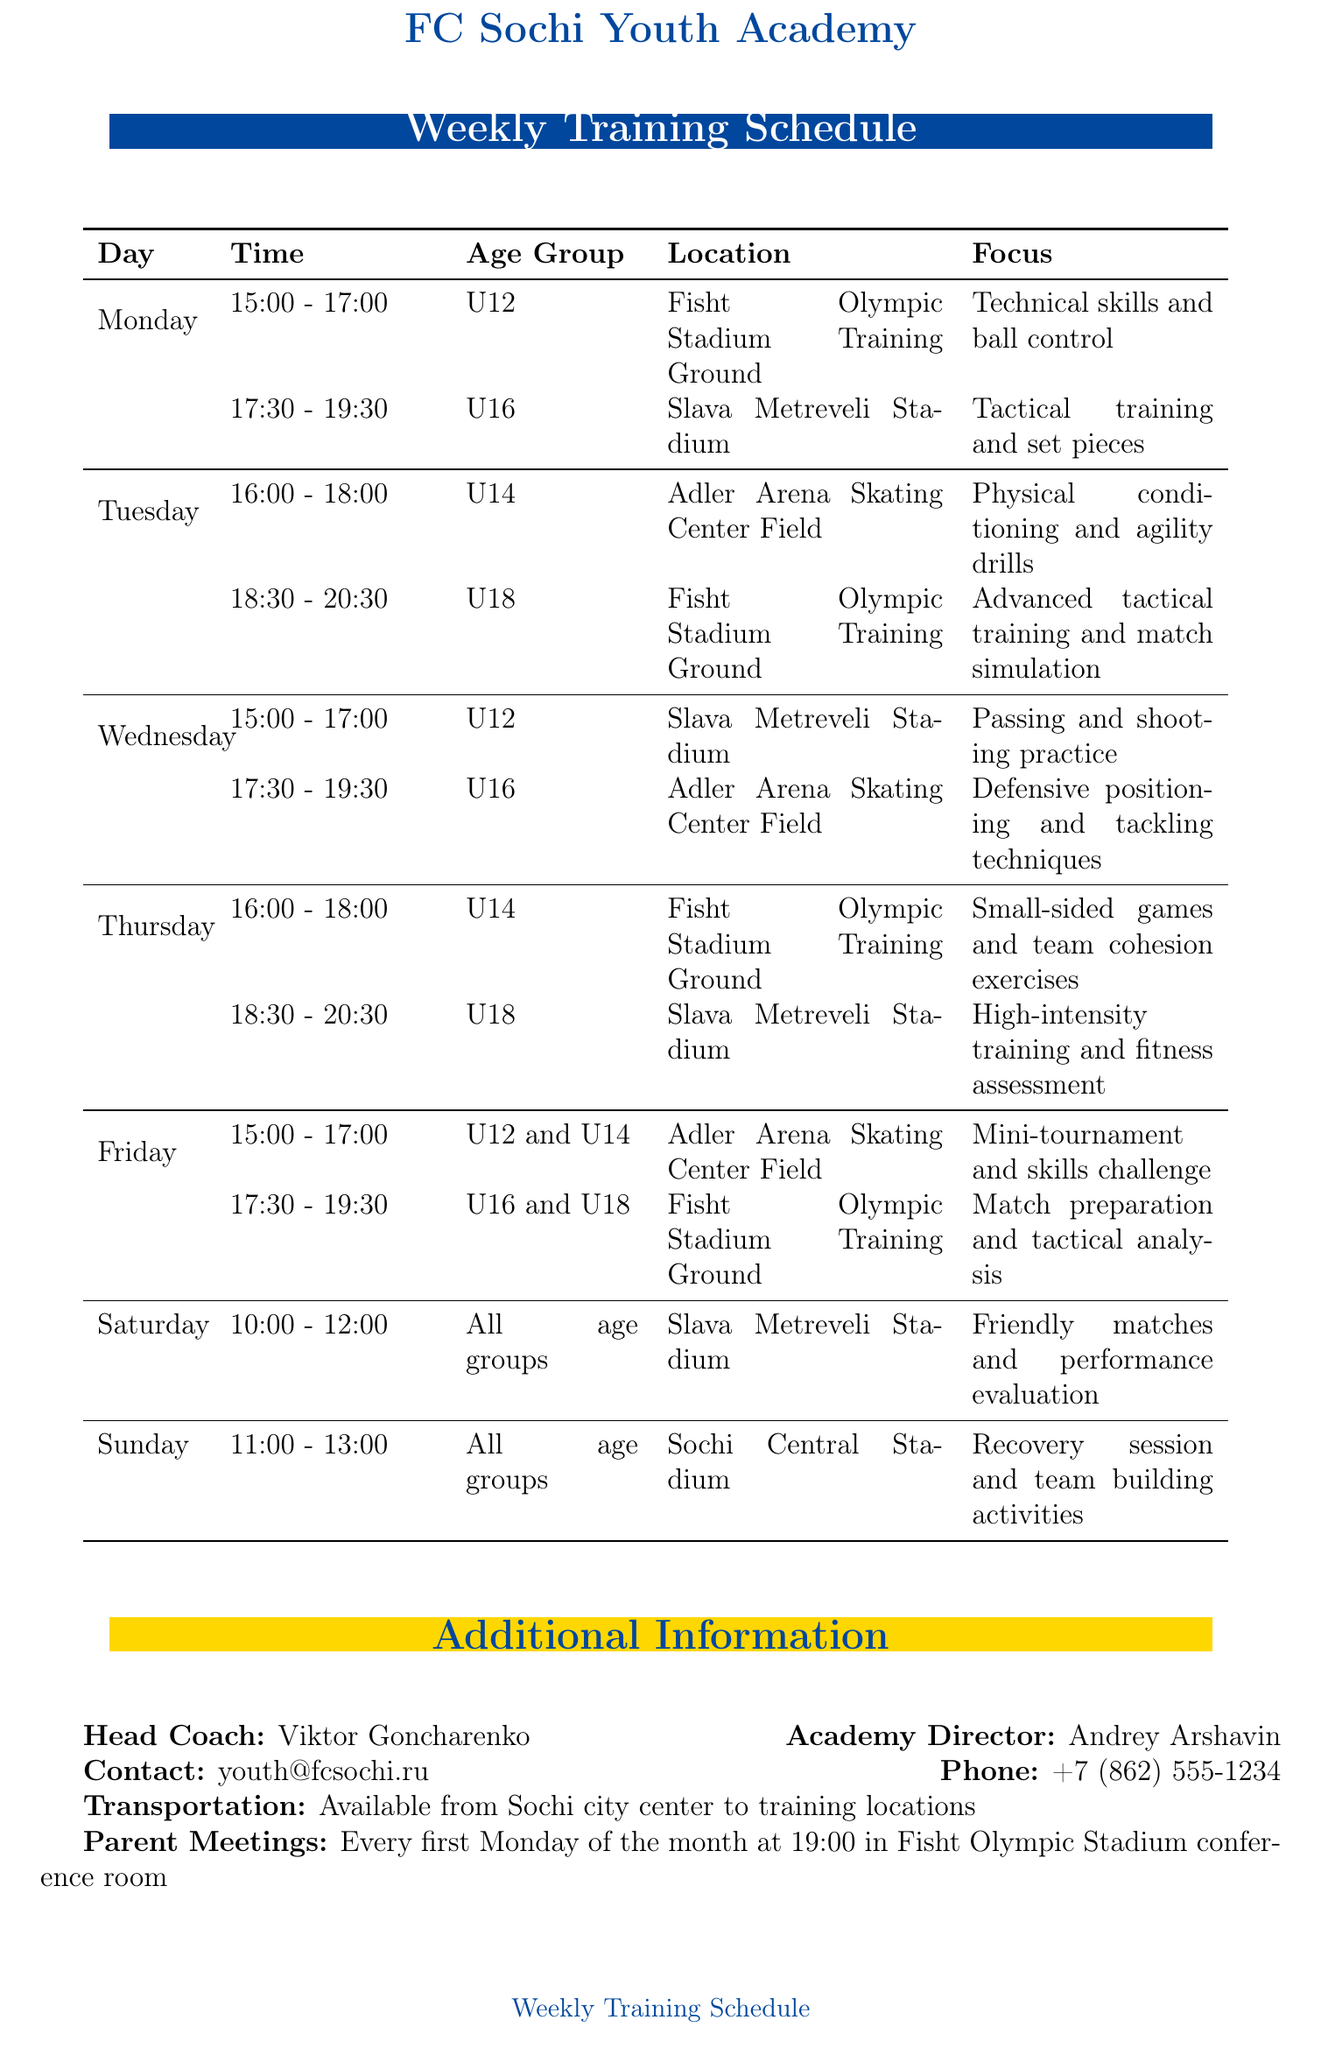What is the head coach's name? The head coach's name is listed in the additional information section of the document.
Answer: Viktor Goncharenko What day is the mini-tournament scheduled? The mini-tournament for U12 and U14 is scheduled on Friday, as detailed in the weekly schedule.
Answer: Friday What age group has practice on Thursday? The practice sessions on Thursday are specified for U14 and U18 age groups in the schedule.
Answer: U14 and U18 How long is the recovery session on Sunday? The duration of the recovery session is mentioned in the Sunday schedule entry, which specifies the training hours.
Answer: 2 hours Which stadium is used for U16 training on Wednesday? The schedule indicates the location for U16 training on Wednesday, which is listed specifically.
Answer: Adler Arena Skating Center Field What is the focus of the U18 training on Tuesday? The focus for U18 on Tuesday is detailed in the session description for that time slot.
Answer: Advanced tactical training and match simulation How many sessions are there on Saturday? The schedule outlines the number of sessions for Saturday based on the day's schedule.
Answer: 1 session When is the next parent meeting? The date and time for parent meetings are given in the additional information section of the document.
Answer: First Monday of the month at 19:00 Where is the FC Sochi Youth Cup held? The location for the FC Sochi Youth Cup is specified in the upcoming events section of the document.
Answer: Fisht Olympic Stadium 